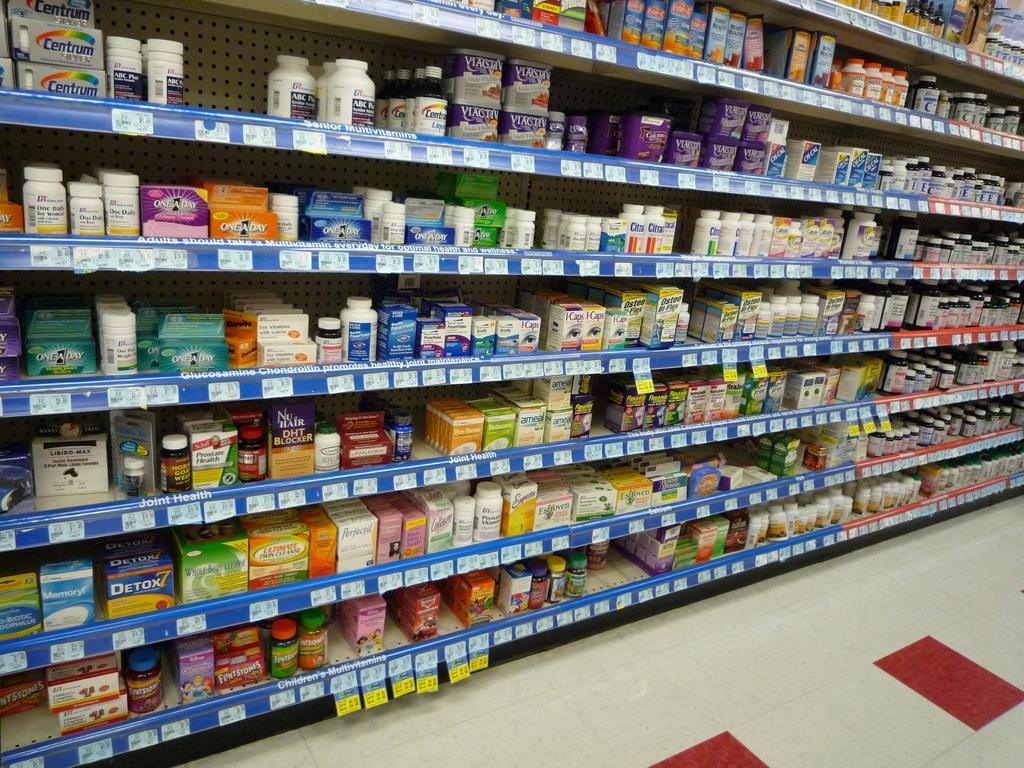How would you summarize this image in a sentence or two? In this image I can see the medical products on the rack shelf. 